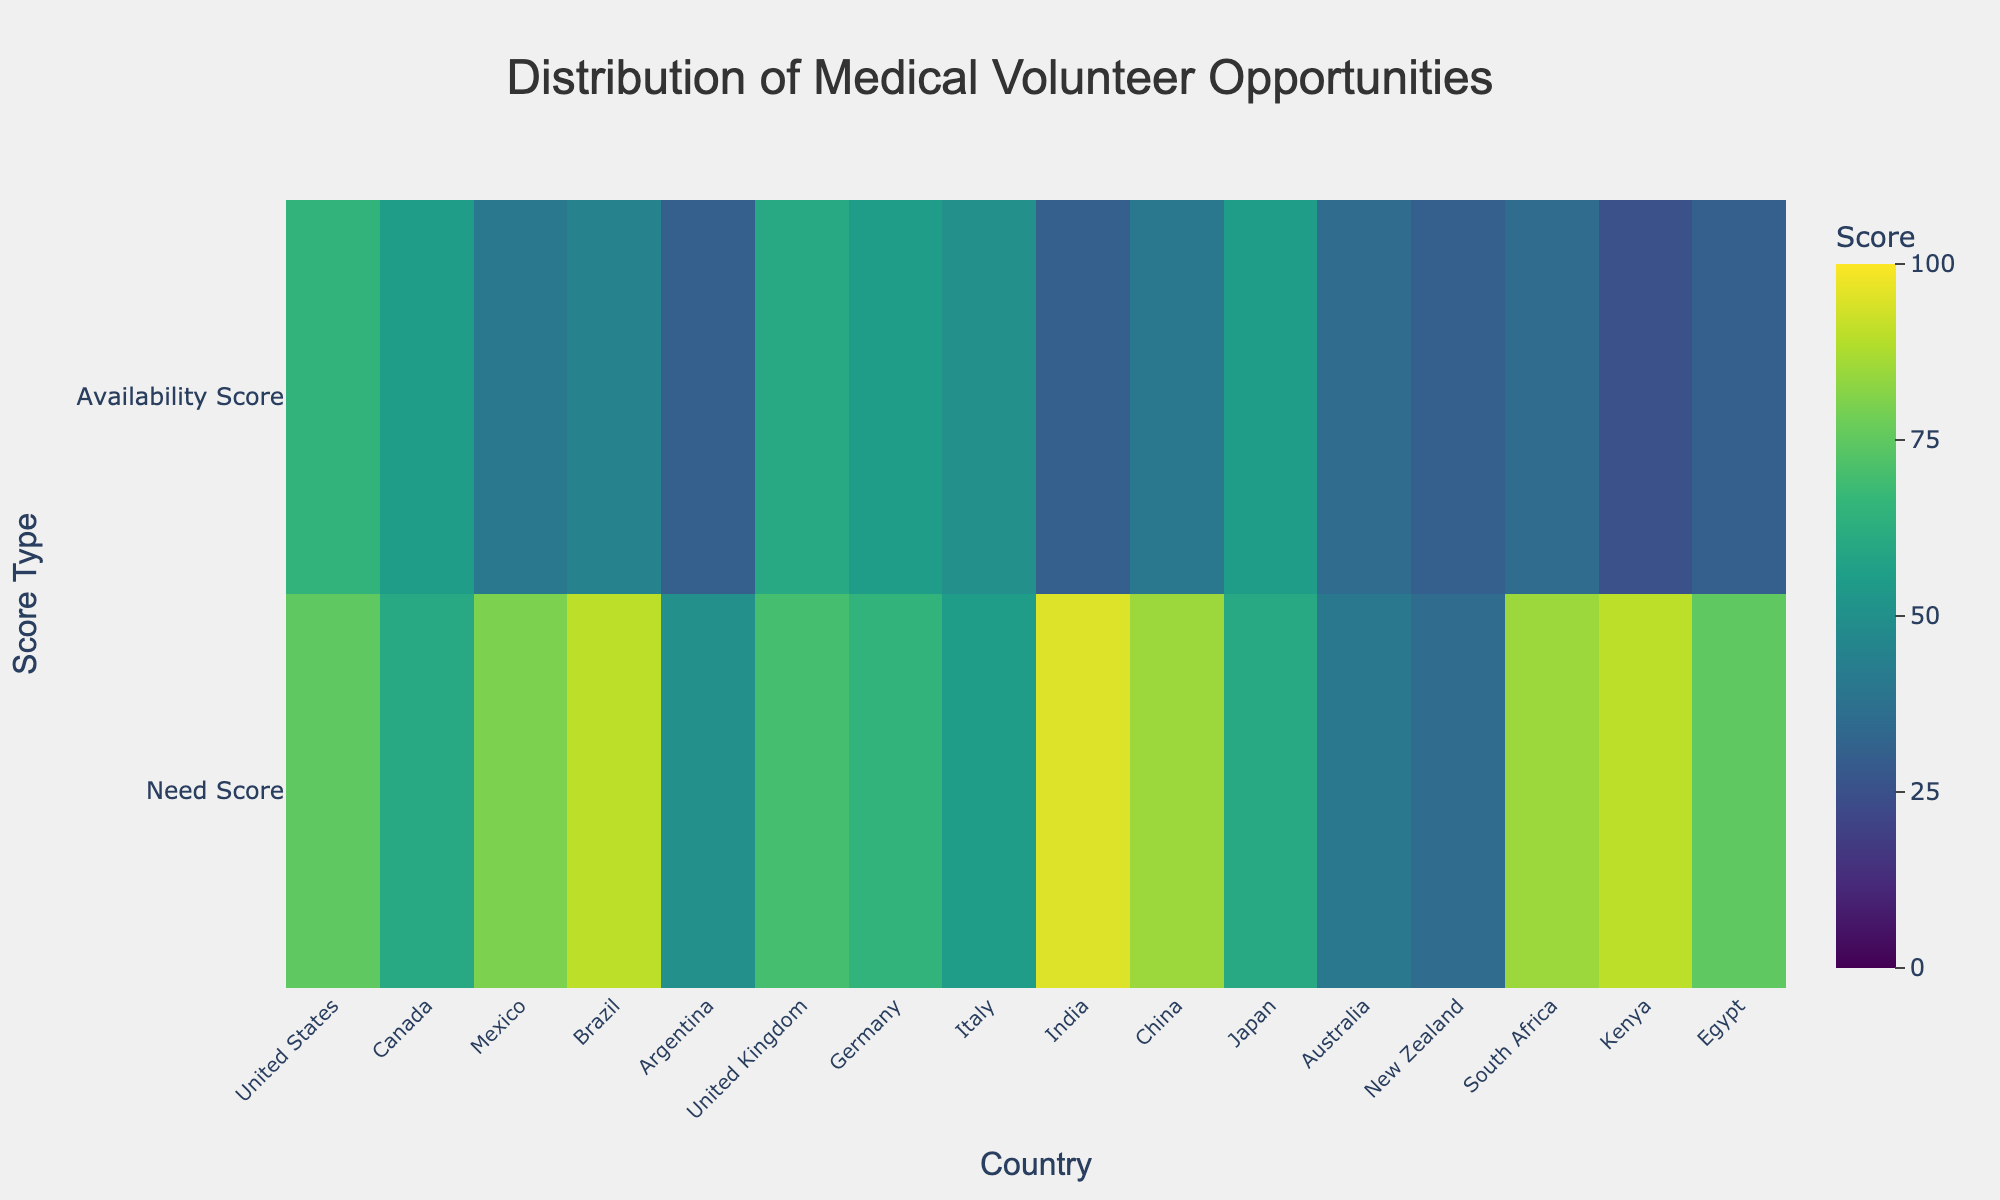what is the title of the figure? The title is displayed at the top center of the figure. It is designed to give an overview of what the figure represents.
Answer: Distribution of Medical Volunteer Opportunities Which country in Asia has the highest need score? Look at the 'Asia' countries' rows under 'Need Score' category and identify the highest value. India has the highest need score in Asia with 95.
Answer: India How do the need and availability scores for South Africa compare? On the heatmap, find South Africa and compare both 'Need Score' and 'Availability Score'. South Africa has a need score of 85 and an availability score of 35.
Answer: Need: 85, Availability: 35 Which region has the overall highest need score based on the visual data? Look at the need scores for the countries within each region. Identify the highest individual need score and the region it belongs to. The highest need score is 95, which is in Asia.
Answer: Asia What is the difference between the need score and availability score for the United Kingdom? Find 'United Kingdom' on the x-axis and compare the scores in the 'Need Score' and 'Availability Score' rows. Subtract the availability score from the need score. The difference is 70 - 60 = 10.
Answer: 10 Which country has the lowest availability score? Scan through the 'Availability Score' row to identify the lowest value and the corresponding country. Kenya has the lowest with a score of 25.
Answer: Kenya Compare the need scores between countries in North America. Which has the greatest need? Look at the 'Need Score' values for countries listed under North America. Compare the scores of the United States and Canada. The United States has the highest need score with 75.
Answer: United States What is the average need score for countries in Europe? Identify the need scores for each European country (United Kingdom, Germany, Italy), sum them up, and divide by the number of countries. (70 + 65 + 55) / 3 = 63.33.
Answer: 63.33 Which two regions have the most significant gap between need and availability scores? Evaluate the difference between need and availability scores for each region, looking for those with the highest disparities. Asia (India: 95-30, China: 85-40) and Africa (Kenya: 90-25, South Africa: 85-35) show the most significant gaps.
Answer: Asia and Africa What are the need and availability scores for Argentina, and how do they compare to Brazil? Find Argentina and Brazil on the heatmap. Compare Need and Availability scores for both. Argentina: 50 (Need), 30 (Availability). Brazil: 90 (Need), 45 (Availability). Argentina has lower scores in both categories compared to Brazil.
Answer: Argentina - Need: 50, Availability: 30; Brazil - Need: 90, Availability: 45 